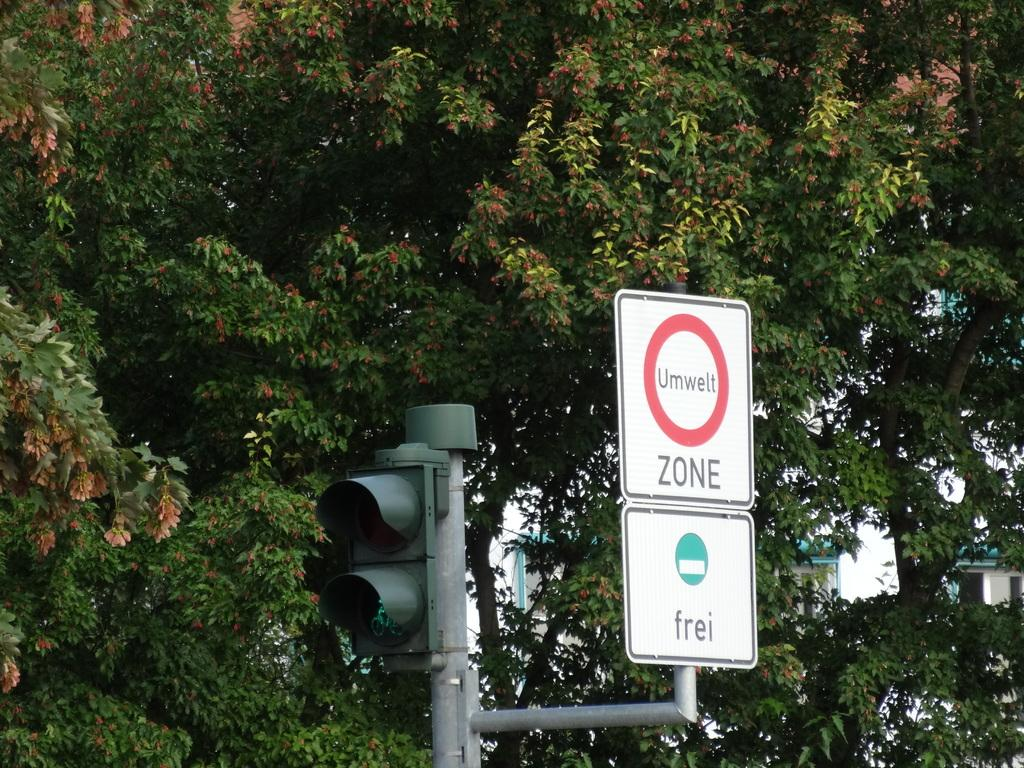<image>
Write a terse but informative summary of the picture. A sign that says Umwelt Zone is next to a traffic signal and there are trees behind it. 